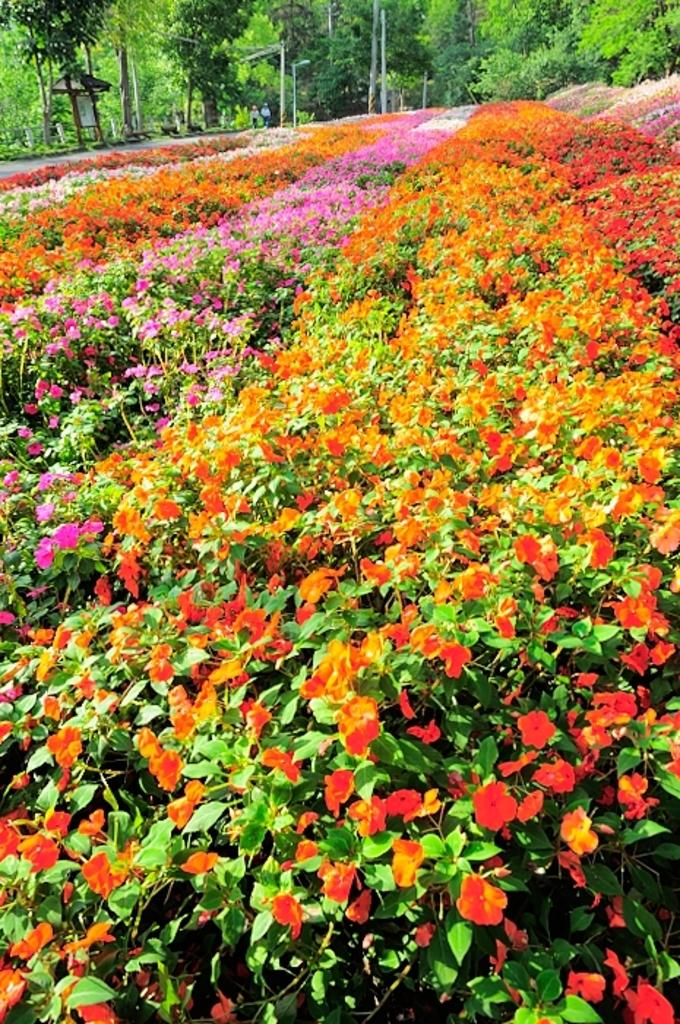What type of living organisms can be seen in the image? Plants can be seen in the image. What distinguishes these plants from others? The plants have colorful features. What can be seen in the background of the image? There are trees and poles in the background of the image. What type of tin can be seen in the image? There is no tin present in the image. What request is being made by the plants in the image? The plants in the image are not making any requests, as they are inanimate objects. 